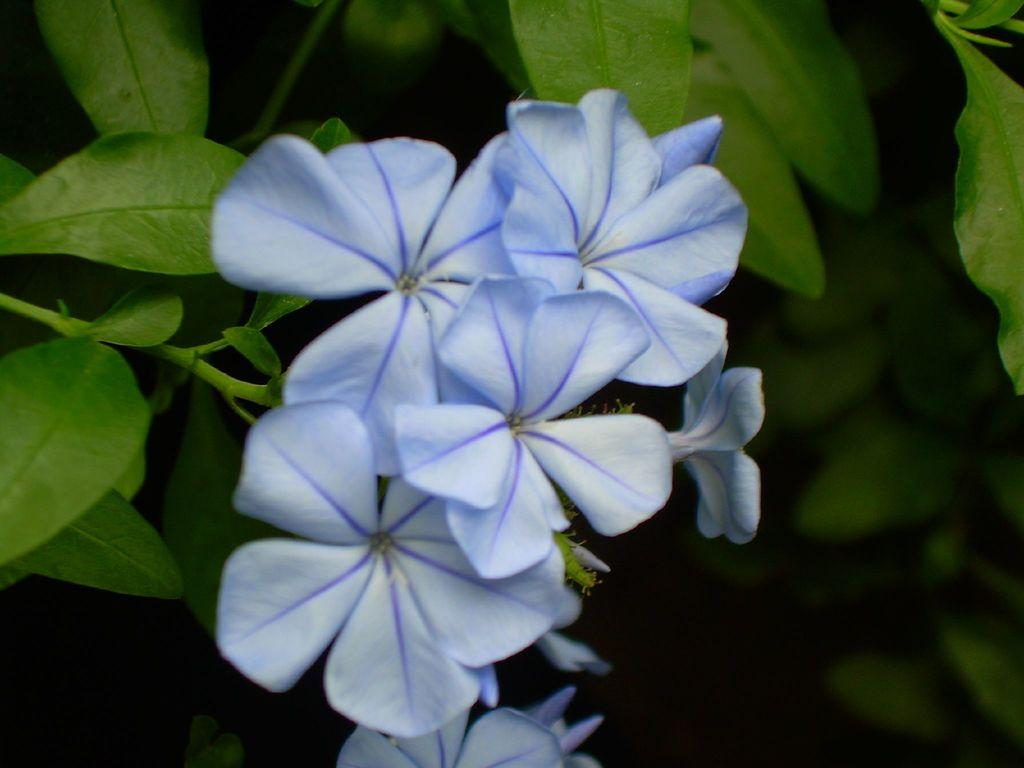What can be seen in the foreground of the picture? There are flowers, leaves, and stems of a plant in the foreground of the picture. What is the color of the background in the image? The background of the image is dark. What type of vegetation is visible in the background? There is greenery in the background of the image. Can you tell me how many ducks are swimming in the background of the image? There are no ducks present in the image; it features only plants and greenery. What type of wave is depicted in the image? There is no wave present in the image; it is a still scene of plants and greenery. 